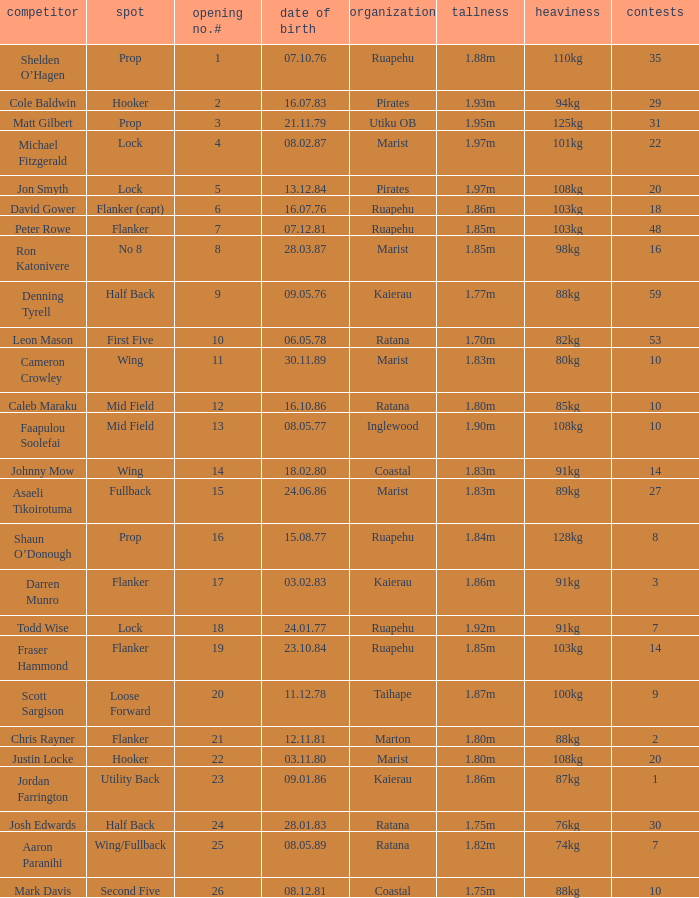Which player weighs 76kg? Josh Edwards. 